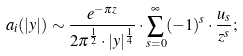Convert formula to latex. <formula><loc_0><loc_0><loc_500><loc_500>\ a _ { i } ( | y | ) \sim \frac { e ^ { - \pi z } } { 2 \pi ^ { \frac { 1 } { 2 } } \cdot | y | ^ { \frac { 1 } { 4 } } } \cdot \sum ^ { \infty } _ { s = 0 } ( - 1 ) ^ { s } \cdot \frac { u _ { s } } { z ^ { s } } ;</formula> 